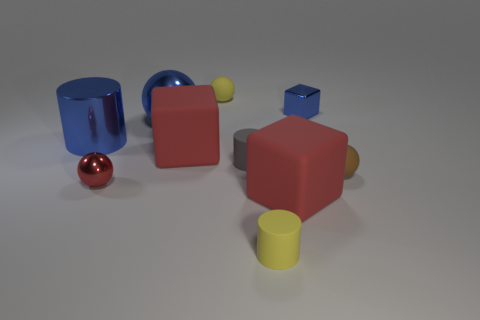How many red rubber blocks are on the left side of the big cube on the right side of the big red rubber thing behind the brown matte sphere?
Your answer should be very brief. 1. Is the color of the metallic cube the same as the large shiny ball that is in front of the yellow rubber ball?
Offer a terse response. Yes. What size is the red object that is made of the same material as the small blue thing?
Keep it short and to the point. Small. Are there more big rubber things to the right of the big blue cylinder than large purple metallic things?
Make the answer very short. Yes. There is a blue cylinder that is behind the tiny matte thing that is in front of the small rubber thing that is right of the yellow matte cylinder; what is it made of?
Provide a short and direct response. Metal. Is the gray cylinder made of the same material as the large red block that is behind the tiny brown thing?
Give a very brief answer. Yes. There is a yellow thing that is the same shape as the small gray thing; what material is it?
Provide a short and direct response. Rubber. Is the number of blue objects to the right of the red ball greater than the number of tiny metallic objects on the right side of the small yellow cylinder?
Your response must be concise. Yes. What shape is the tiny gray object that is the same material as the tiny yellow cylinder?
Provide a short and direct response. Cylinder. How many other objects are the same shape as the tiny red object?
Your response must be concise. 3. 